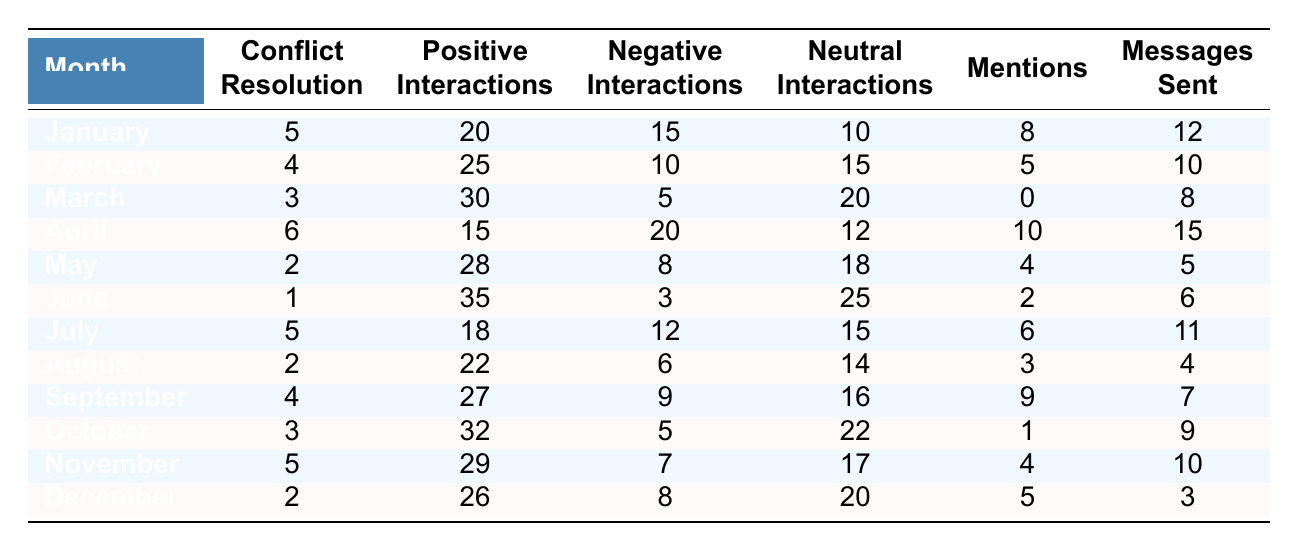What month had the highest number of positive interactions? By examining the "Positive Interactions" column, we find that June has the highest value with 35 positive interactions.
Answer: June What was the total number of conflict resolution attempts over the year? By adding the values in the "Conflict Resolution" column: 5 + 4 + 3 + 6 + 2 + 1 + 5 + 2 + 4 + 3 + 5 + 2 = 42.
Answer: 42 How many mentions were recorded in September? Referring to the "Mentions" column, September shows 9 mentions.
Answer: 9 Which month had the lowest number of conflict resolution attempts? Looking at the "Conflict Resolution" column, June has the lowest value at 1 attempt.
Answer: June Is it true that there were more positive interactions than negative interactions in every month? Checking month by month: January, February, March, May, June, September, October, and November show more positive than negative interactions, while April and July do not. Thus, the statement is false.
Answer: No What was the average number of negative interactions for the months from January to December? Calculating the average: Total negative interactions are 15 + 10 + 5 + 20 + 8 + 3 + 12 + 6 + 9 + 5 + 7 + 8 = 104. With 12 months, the average is 104/12 = 8.67.
Answer: 8.67 How many months had positive interactions greater than 25? From the "Positive Interactions" column, the months with values greater than 25 are February, March, May, June, September, October, and November—totaling 7 months.
Answer: 7 Which month had the highest number of negative interactions? Checking the "Negative Interactions" column, April has the highest value with 20 negative interactions.
Answer: April What was the difference in the number of messages sent between January and December? The values are 12 for January and 3 for December. The difference is 12 - 3 = 9 messages sent.
Answer: 9 In how many months were there more neutral interactions than negative interactions? We compare the "Neutral" and "Negative" columns: January, February, March, May, June, August, September, October, November, and December show more neutral than negative interactions—totaling 10 months.
Answer: 10 